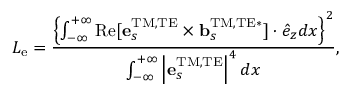<formula> <loc_0><loc_0><loc_500><loc_500>L _ { e } = \frac { \left \{ \int _ { - \infty } ^ { + \infty } R e [ { e } _ { s } ^ { T M , T E } \times { b } _ { s } ^ { T M , T E * } ] \cdot \hat { e } _ { z } d x \right \} ^ { 2 } } { \int _ { - \infty } ^ { + \infty } \left | { e } _ { s } ^ { T M , T E } \right | ^ { 4 } d x } ,</formula> 